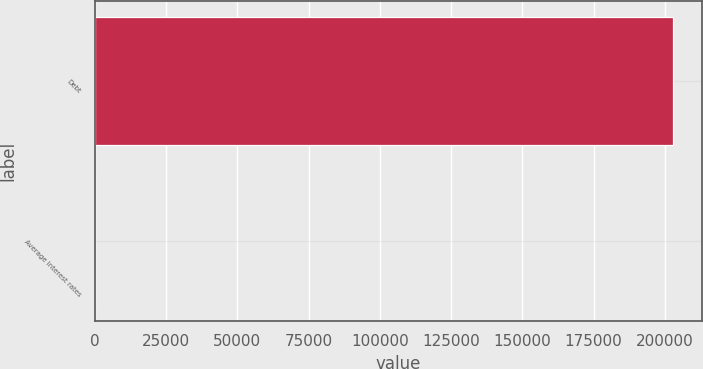Convert chart. <chart><loc_0><loc_0><loc_500><loc_500><bar_chart><fcel>Debt<fcel>Average interest rates<nl><fcel>202814<fcel>7<nl></chart> 